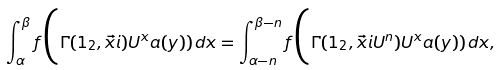<formula> <loc_0><loc_0><loc_500><loc_500>\int _ { \alpha } ^ { \beta } f \Big ( \Gamma ( 1 _ { 2 } , \vec { x } i ) U ^ { x } a ( y ) ) \, d x = \int _ { \alpha - n } ^ { \beta - n } f \Big ( \Gamma ( 1 _ { 2 } , \vec { x } i U ^ { n } ) U ^ { x } a ( y ) ) \, d x ,</formula> 